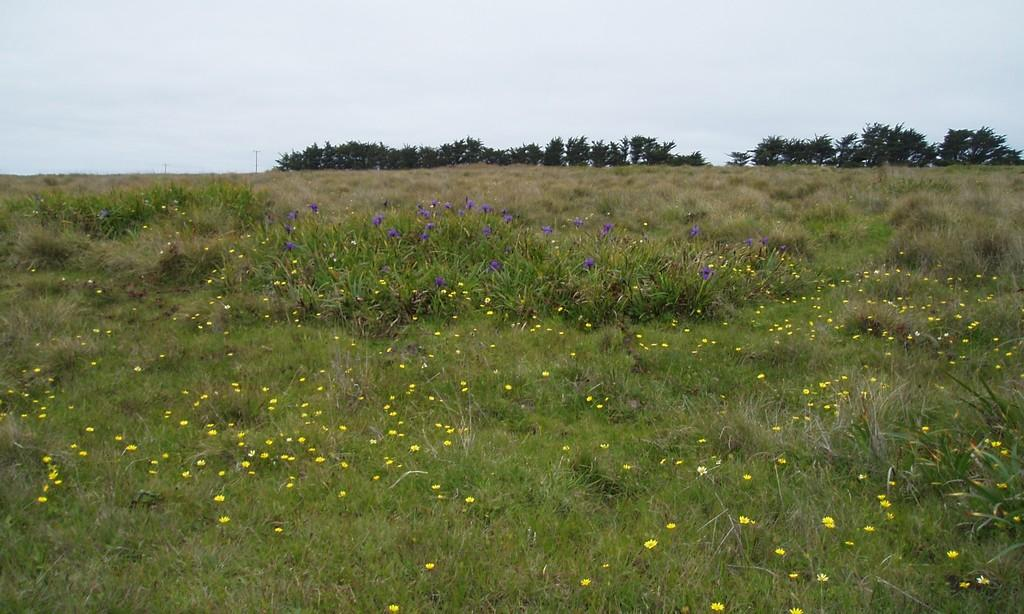What type of vegetation can be seen in the image? There is grass in the image, along with yellow and purple flowers. What other natural elements are present in the image? There are trees in the background of the image. What can be seen in the sky in the image? The sky is visible in the background of the image. What type of dinner is being served in the image? There is no dinner present in the image; it features natural elements such as grass, flowers, trees, and the sky. 